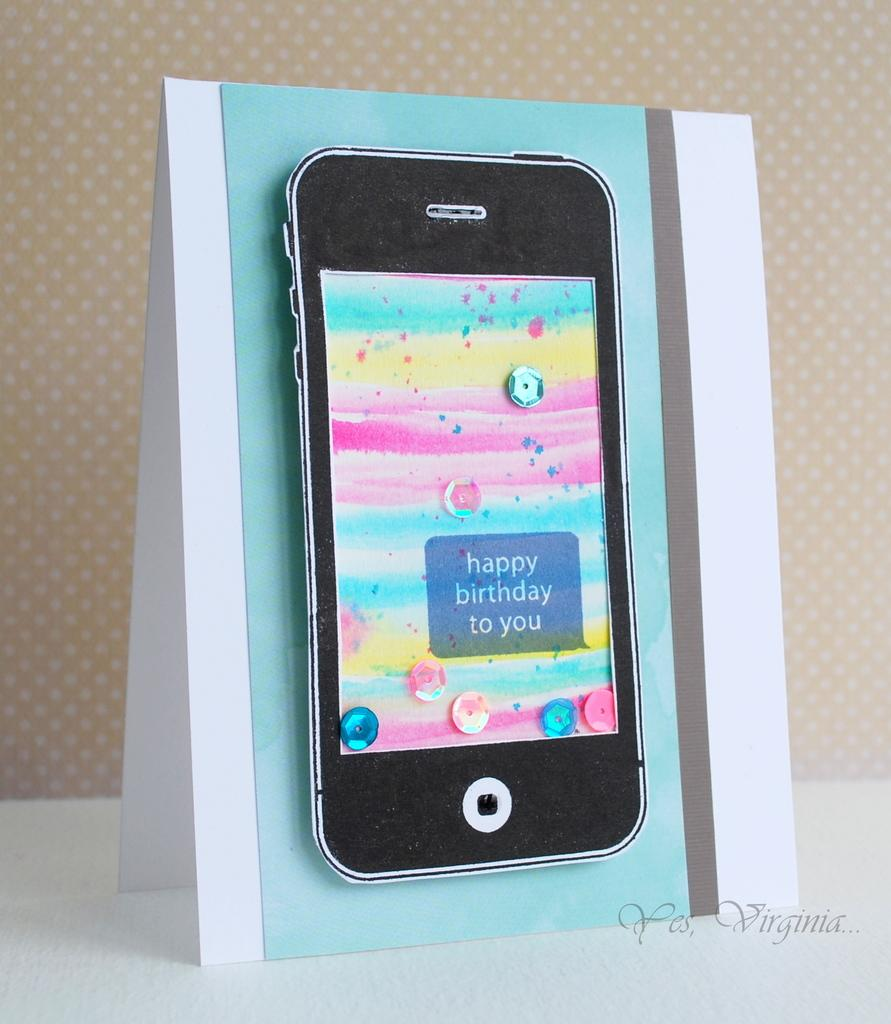<image>
Describe the image concisely. A phone has a birthday message on the screen. 